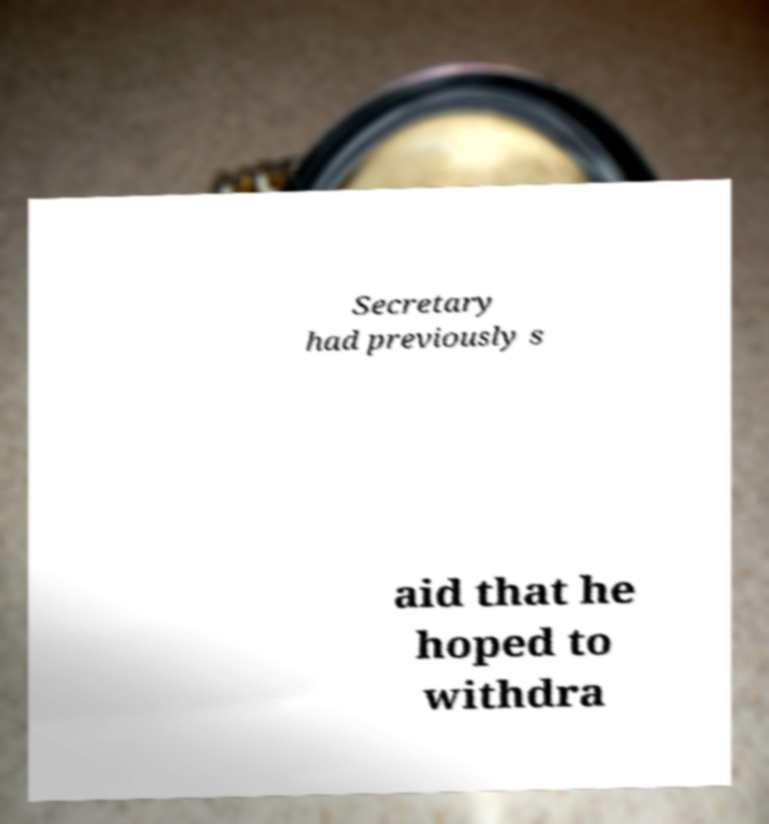I need the written content from this picture converted into text. Can you do that? Secretary had previously s aid that he hoped to withdra 